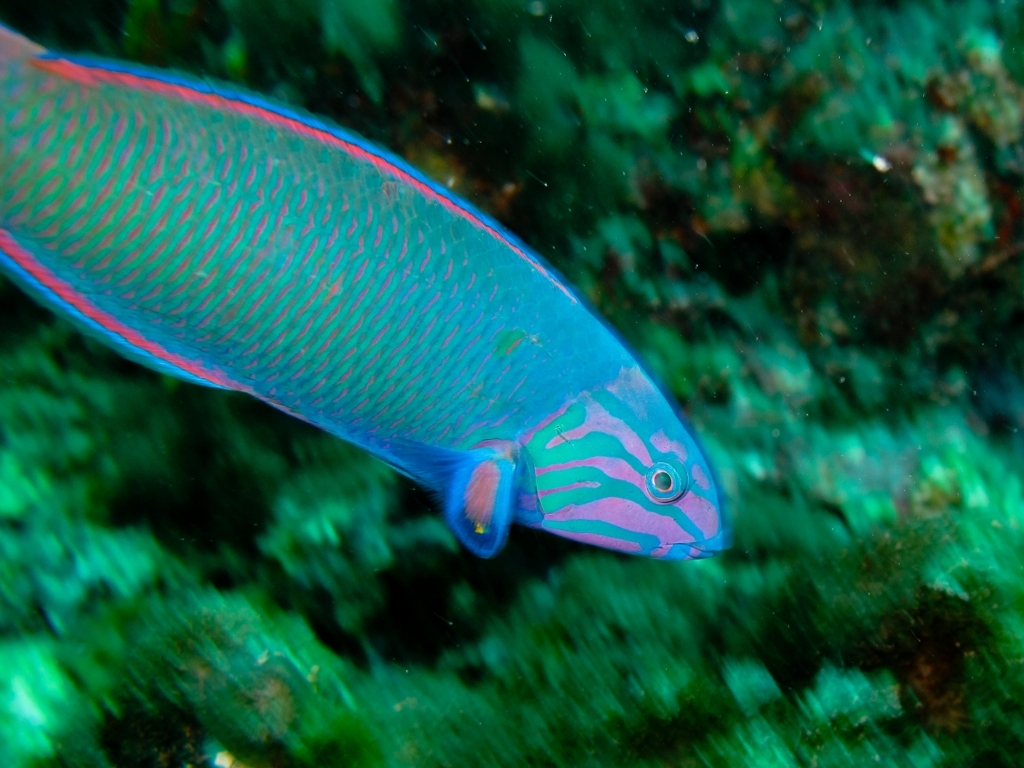Are there minimal details in the background?
A. No
B. Yes
Answer with the option's letter from the given choices directly.
 B. 